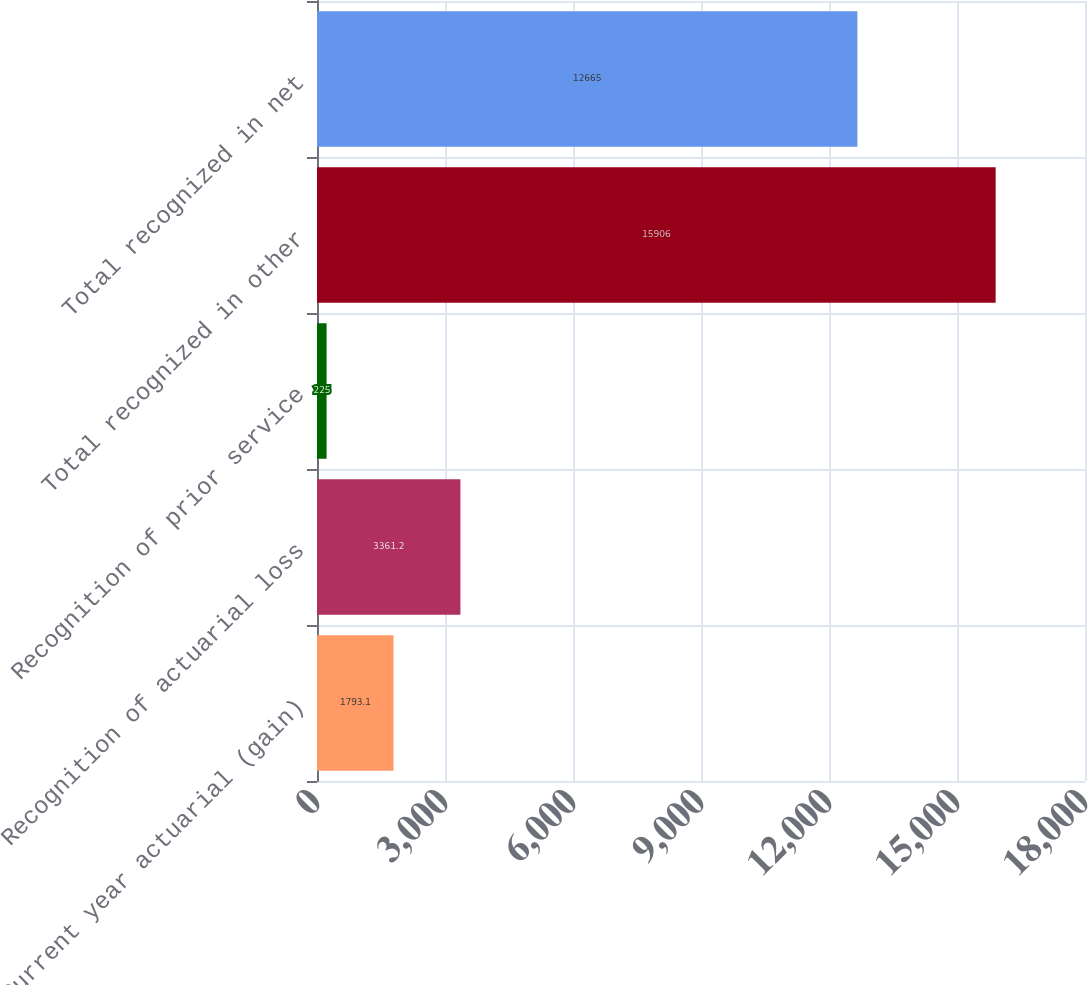Convert chart to OTSL. <chart><loc_0><loc_0><loc_500><loc_500><bar_chart><fcel>Current year actuarial (gain)<fcel>Recognition of actuarial loss<fcel>Recognition of prior service<fcel>Total recognized in other<fcel>Total recognized in net<nl><fcel>1793.1<fcel>3361.2<fcel>225<fcel>15906<fcel>12665<nl></chart> 